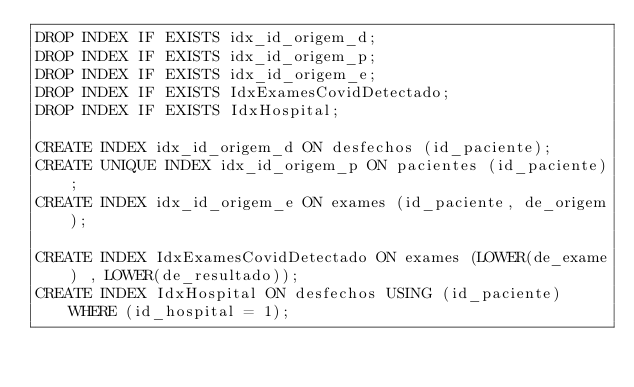<code> <loc_0><loc_0><loc_500><loc_500><_SQL_>DROP INDEX IF EXISTS idx_id_origem_d;
DROP INDEX IF EXISTS idx_id_origem_p;
DROP INDEX IF EXISTS idx_id_origem_e;
DROP INDEX IF EXISTS IdxExamesCovidDetectado;
DROP INDEX IF EXISTS IdxHospital;

CREATE INDEX idx_id_origem_d ON desfechos (id_paciente);
CREATE UNIQUE INDEX idx_id_origem_p ON pacientes (id_paciente);
CREATE INDEX idx_id_origem_e ON exames (id_paciente, de_origem);

CREATE INDEX IdxExamesCovidDetectado ON exames (LOWER(de_exame) , LOWER(de_resultado));
CREATE INDEX IdxHospital ON desfechos USING (id_paciente) WHERE (id_hospital = 1);</code> 